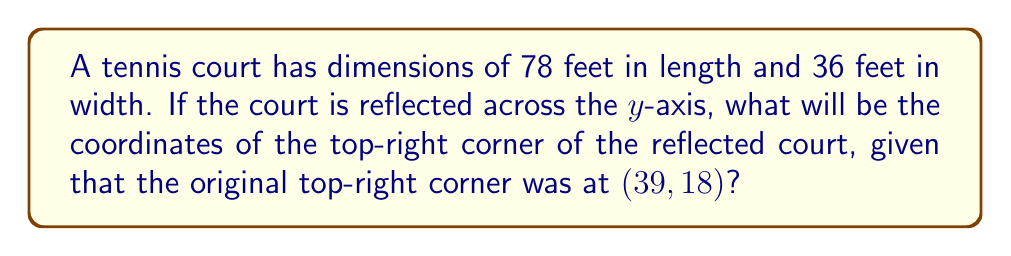Give your solution to this math problem. Let's approach this step-by-step:

1) The original top-right corner is at (39, 18).

2) When reflecting across the y-axis, the x-coordinate changes sign, while the y-coordinate remains the same.

3) The reflection transformation across the y-axis can be represented as:
   $$(x, y) \rightarrow (-x, y)$$

4) Applying this transformation to our point (39, 18):
   $$\begin{align*}
   x &= -(39) = -39 \\
   y &= 18
   \end{align*}$$

5) Therefore, the reflected point will be at (-39, 18).

[asy]
unitsize(3mm);
draw((-40,-20)--(40,-20)--(40,20)--(-40,20)--cycle);
draw((0,-20)--(0,20), dashed);
dot((39,18));
dot((-39,18));
label("Original", (39,18), E);
label("Reflected", (-39,18), W);
label("y-axis", (0,21), N);
[/asy]
Answer: (-39, 18) 